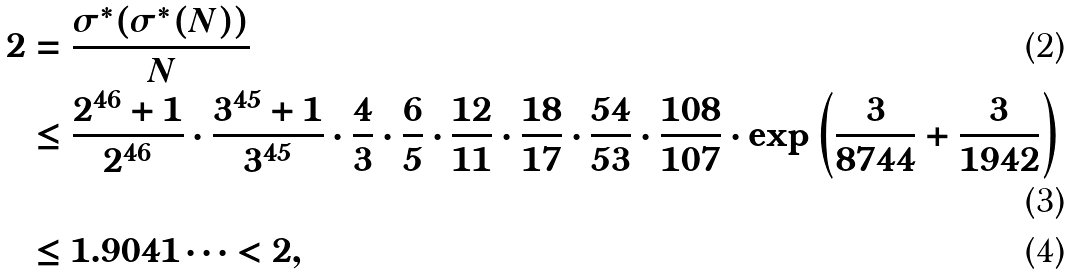Convert formula to latex. <formula><loc_0><loc_0><loc_500><loc_500>2 & = \frac { \sigma ^ { * } ( \sigma ^ { * } ( N ) ) } { N } \\ & \leq \frac { 2 ^ { 4 6 } + 1 } { 2 ^ { 4 6 } } \cdot \frac { 3 ^ { 4 5 } + 1 } { 3 ^ { 4 5 } } \cdot \frac { 4 } { 3 } \cdot \frac { 6 } { 5 } \cdot \frac { 1 2 } { 1 1 } \cdot \frac { 1 8 } { 1 7 } \cdot \frac { 5 4 } { 5 3 } \cdot \frac { 1 0 8 } { 1 0 7 } \cdot \exp \left ( \frac { 3 } { 8 7 4 4 } + \frac { 3 } { 1 9 4 2 } \right ) \\ & \leq 1 . 9 0 4 1 \cdots < 2 ,</formula> 